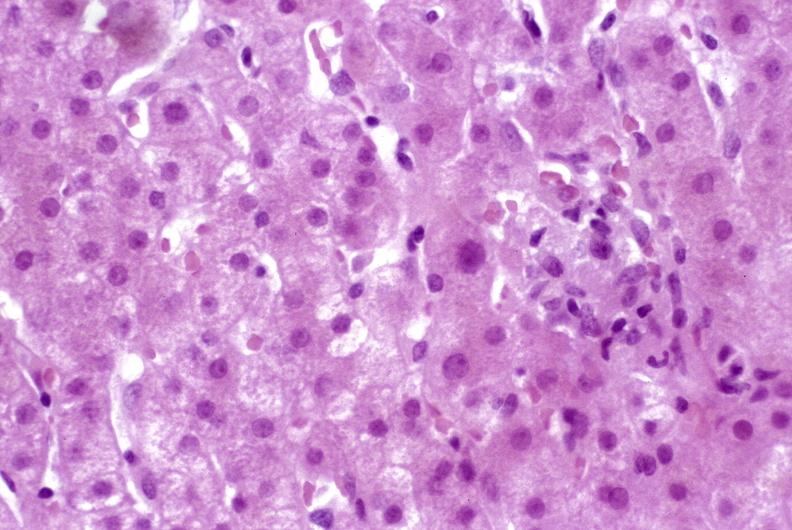what is present?
Answer the question using a single word or phrase. Liver 